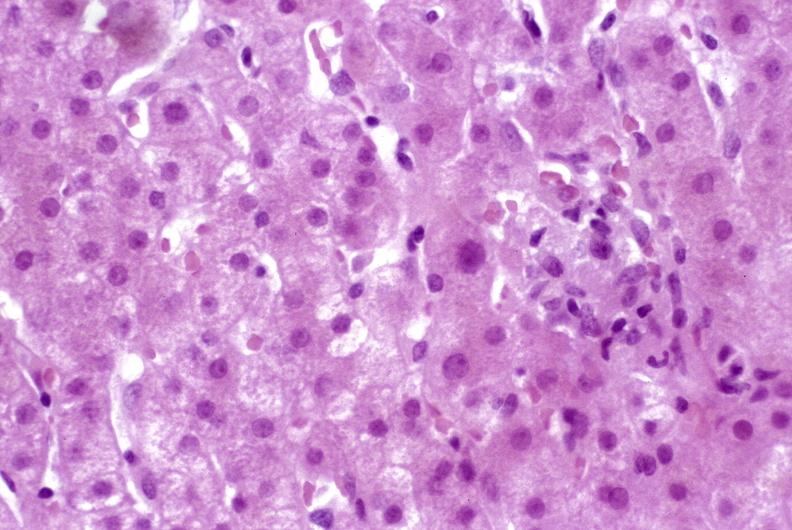what is present?
Answer the question using a single word or phrase. Liver 